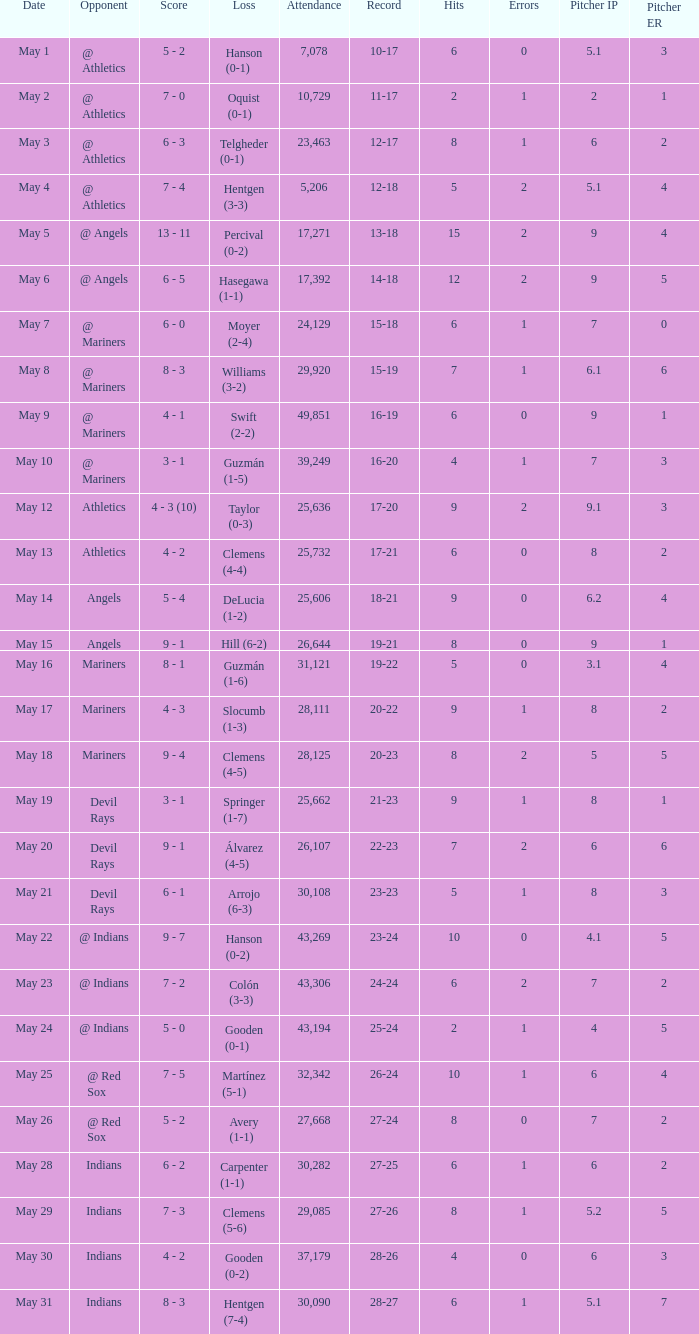When the record is 16-20 and attendance is greater than 32,342, what is the score? 3 - 1. 